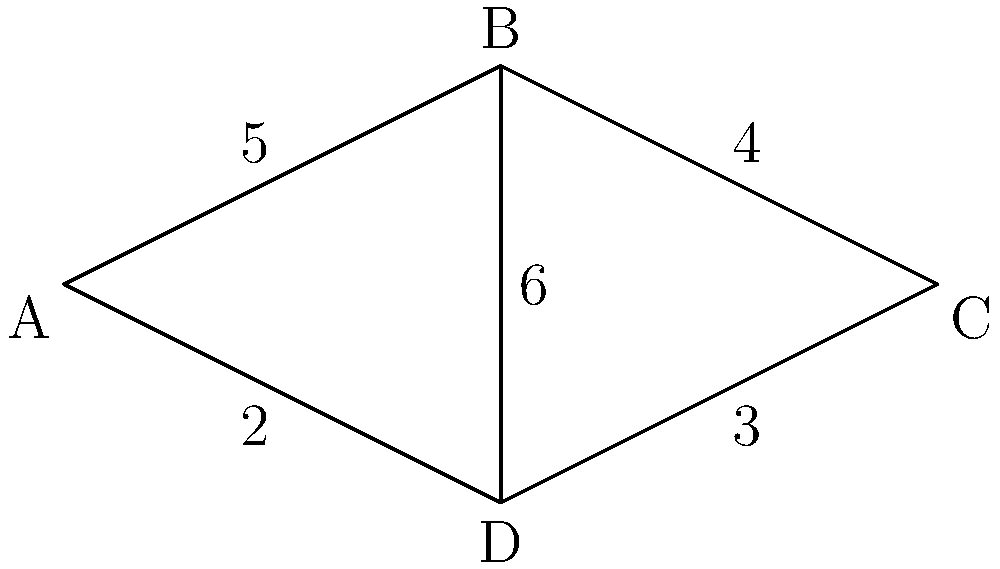In your quarry, you need to optimize the layout of conveyor belts connecting different processing areas. The network diagram above represents the possible connections between areas A, B, C, and D, with the numbers indicating the cost (in thousands of dollars) to install conveyor belts between each pair of areas. What is the minimum total cost to connect all four areas? To find the minimum total cost to connect all four areas, we need to find the minimum spanning tree of the given network. We can use Kruskal's algorithm to solve this problem:

1. Sort all edges by their weight (cost) in ascending order:
   AD (2), CD (3), BC (4), AB (5), BD (6)

2. Start with an empty set of edges and add edges one by one, skipping any that would create a cycle:
   - Add AD (2)
   - Add CD (3)
   - Add BC (4)

3. After adding these three edges, we have connected all four nodes without creating any cycles. The algorithm stops here.

4. Sum up the costs of the selected edges:
   $2 + 3 + 4 = 9$

Therefore, the minimum total cost to connect all four areas is $9,000.
Answer: $9,000 